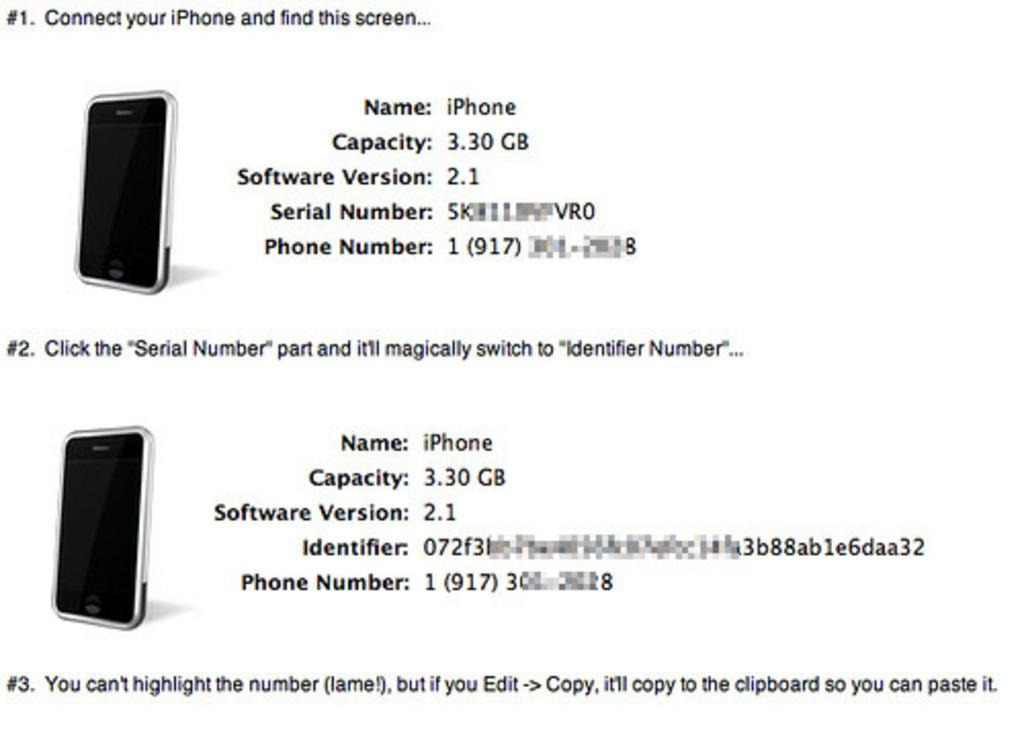<image>
Describe the image concisely. Informational guide on how to get your identifier number on an iPhone. 